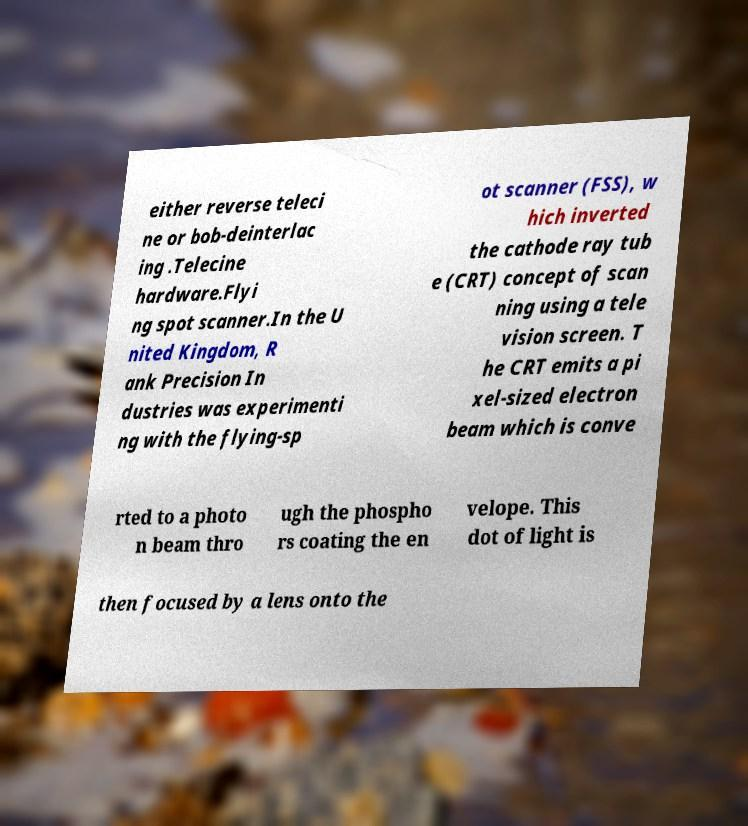I need the written content from this picture converted into text. Can you do that? either reverse teleci ne or bob-deinterlac ing .Telecine hardware.Flyi ng spot scanner.In the U nited Kingdom, R ank Precision In dustries was experimenti ng with the flying-sp ot scanner (FSS), w hich inverted the cathode ray tub e (CRT) concept of scan ning using a tele vision screen. T he CRT emits a pi xel-sized electron beam which is conve rted to a photo n beam thro ugh the phospho rs coating the en velope. This dot of light is then focused by a lens onto the 